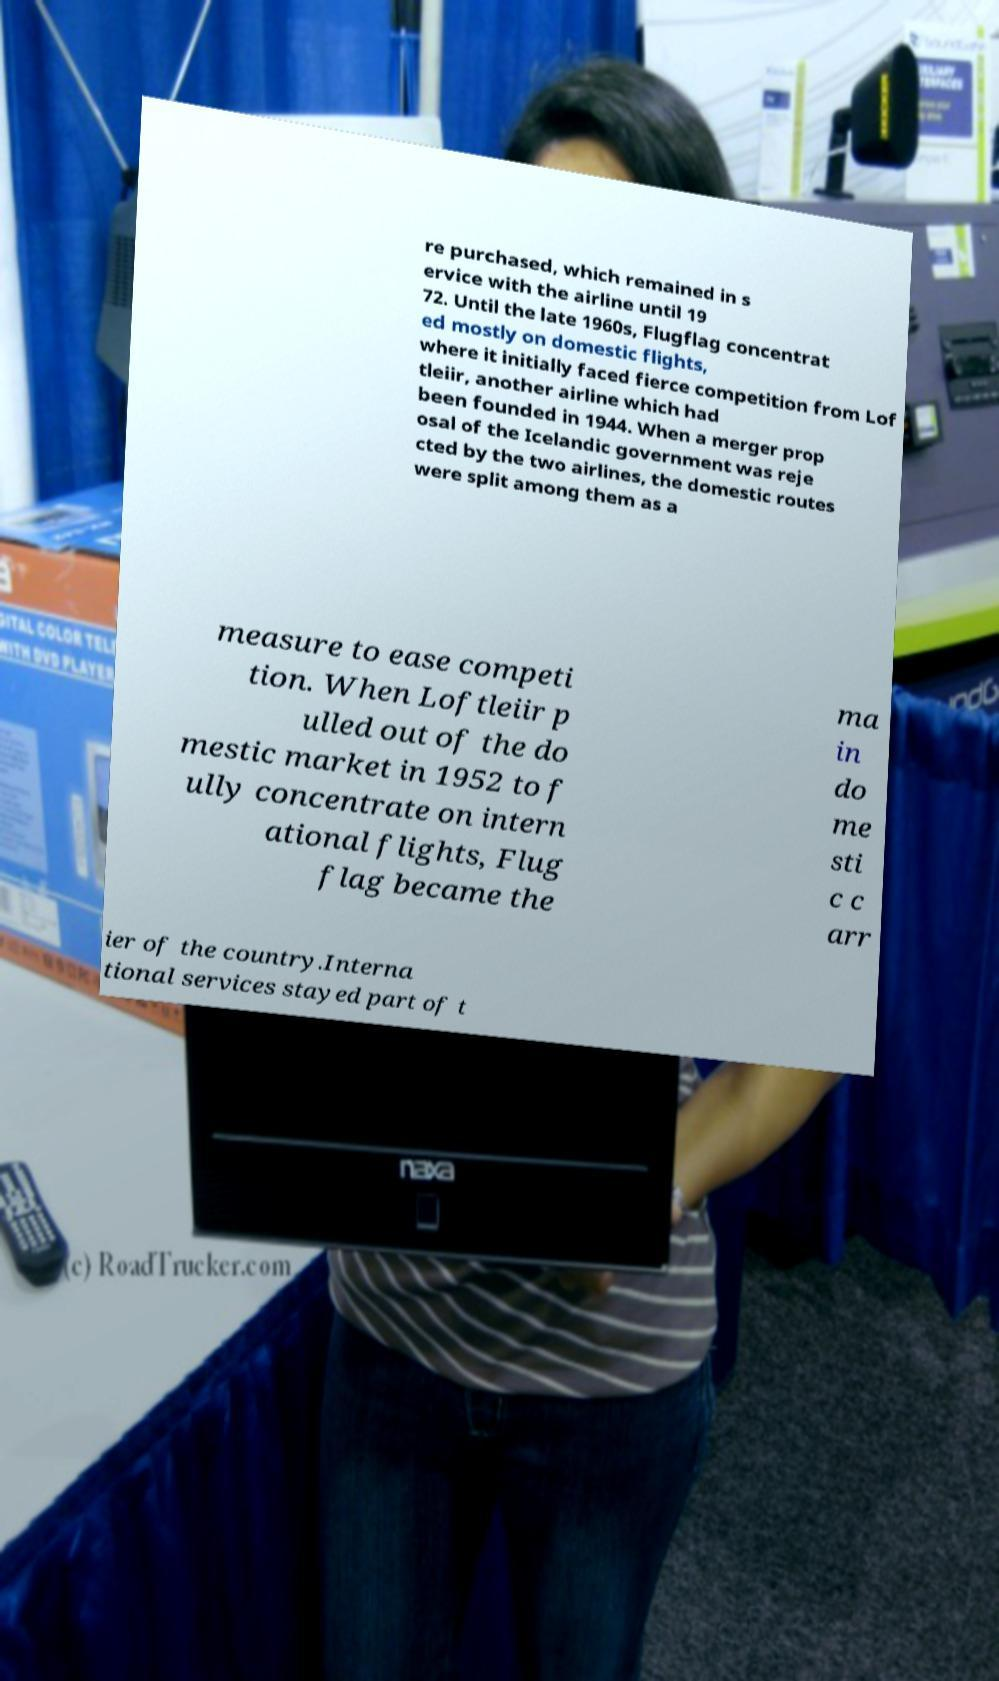Could you extract and type out the text from this image? re purchased, which remained in s ervice with the airline until 19 72. Until the late 1960s, Flugflag concentrat ed mostly on domestic flights, where it initially faced fierce competition from Lof tleiir, another airline which had been founded in 1944. When a merger prop osal of the Icelandic government was reje cted by the two airlines, the domestic routes were split among them as a measure to ease competi tion. When Loftleiir p ulled out of the do mestic market in 1952 to f ully concentrate on intern ational flights, Flug flag became the ma in do me sti c c arr ier of the country.Interna tional services stayed part of t 